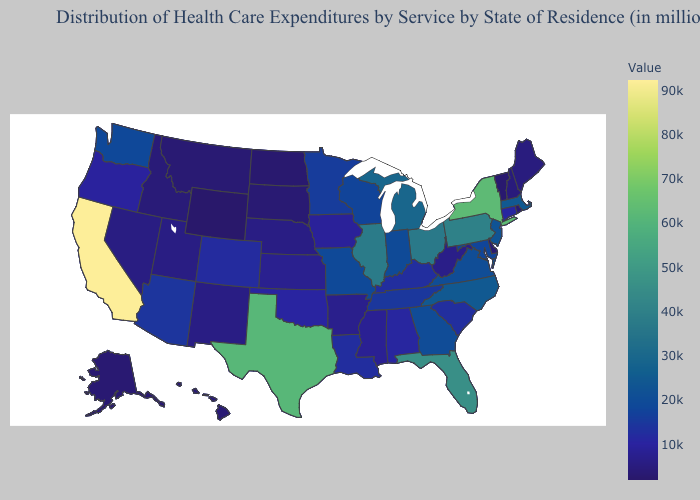Does Wyoming have a higher value than Michigan?
Short answer required. No. Does Pennsylvania have the highest value in the USA?
Be succinct. No. Does New Jersey have the lowest value in the Northeast?
Be succinct. No. Which states hav the highest value in the South?
Keep it brief. Texas. Does Oregon have a lower value than Missouri?
Concise answer only. Yes. 